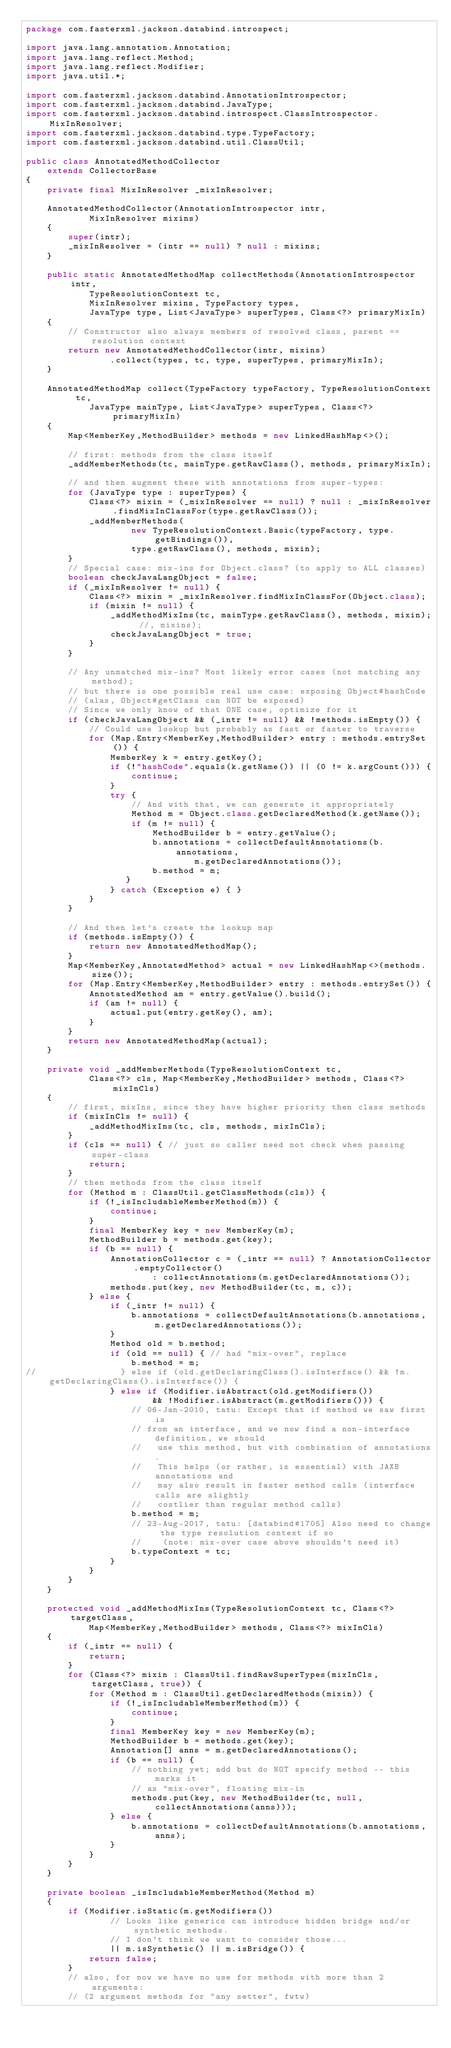<code> <loc_0><loc_0><loc_500><loc_500><_Java_>package com.fasterxml.jackson.databind.introspect;

import java.lang.annotation.Annotation;
import java.lang.reflect.Method;
import java.lang.reflect.Modifier;
import java.util.*;

import com.fasterxml.jackson.databind.AnnotationIntrospector;
import com.fasterxml.jackson.databind.JavaType;
import com.fasterxml.jackson.databind.introspect.ClassIntrospector.MixInResolver;
import com.fasterxml.jackson.databind.type.TypeFactory;
import com.fasterxml.jackson.databind.util.ClassUtil;

public class AnnotatedMethodCollector
    extends CollectorBase
{
    private final MixInResolver _mixInResolver;

    AnnotatedMethodCollector(AnnotationIntrospector intr,
            MixInResolver mixins)
    {
        super(intr);
        _mixInResolver = (intr == null) ? null : mixins;
    }

    public static AnnotatedMethodMap collectMethods(AnnotationIntrospector intr,
            TypeResolutionContext tc,
            MixInResolver mixins, TypeFactory types,
            JavaType type, List<JavaType> superTypes, Class<?> primaryMixIn)
    {
        // Constructor also always members of resolved class, parent == resolution context
        return new AnnotatedMethodCollector(intr, mixins)
                .collect(types, tc, type, superTypes, primaryMixIn);
    }

    AnnotatedMethodMap collect(TypeFactory typeFactory, TypeResolutionContext tc,
            JavaType mainType, List<JavaType> superTypes, Class<?> primaryMixIn)
    {
        Map<MemberKey,MethodBuilder> methods = new LinkedHashMap<>();
        
        // first: methods from the class itself
        _addMemberMethods(tc, mainType.getRawClass(), methods, primaryMixIn);

        // and then augment these with annotations from super-types:
        for (JavaType type : superTypes) {
            Class<?> mixin = (_mixInResolver == null) ? null : _mixInResolver.findMixInClassFor(type.getRawClass());
            _addMemberMethods(
                    new TypeResolutionContext.Basic(typeFactory, type.getBindings()),
                    type.getRawClass(), methods, mixin);
        }
        // Special case: mix-ins for Object.class? (to apply to ALL classes)
        boolean checkJavaLangObject = false;
        if (_mixInResolver != null) {
            Class<?> mixin = _mixInResolver.findMixInClassFor(Object.class);
            if (mixin != null) {
                _addMethodMixIns(tc, mainType.getRawClass(), methods, mixin); //, mixins);
                checkJavaLangObject = true;
            }
        }

        // Any unmatched mix-ins? Most likely error cases (not matching any method);
        // but there is one possible real use case: exposing Object#hashCode
        // (alas, Object#getClass can NOT be exposed)
        // Since we only know of that ONE case, optimize for it
        if (checkJavaLangObject && (_intr != null) && !methods.isEmpty()) {
            // Could use lookup but probably as fast or faster to traverse
            for (Map.Entry<MemberKey,MethodBuilder> entry : methods.entrySet()) {
                MemberKey k = entry.getKey();
                if (!"hashCode".equals(k.getName()) || (0 != k.argCount())) {
                    continue;
                }
                try {
                    // And with that, we can generate it appropriately
                    Method m = Object.class.getDeclaredMethod(k.getName());
                    if (m != null) {
                        MethodBuilder b = entry.getValue();
                        b.annotations = collectDefaultAnnotations(b.annotations,
                                m.getDeclaredAnnotations());
                        b.method = m;
                   }
                } catch (Exception e) { }
            }
        }

        // And then let's create the lookup map
        if (methods.isEmpty()) {
            return new AnnotatedMethodMap();
        }
        Map<MemberKey,AnnotatedMethod> actual = new LinkedHashMap<>(methods.size());
        for (Map.Entry<MemberKey,MethodBuilder> entry : methods.entrySet()) {
            AnnotatedMethod am = entry.getValue().build();
            if (am != null) {
                actual.put(entry.getKey(), am);
            }
        }
        return new AnnotatedMethodMap(actual);
    }

    private void _addMemberMethods(TypeResolutionContext tc,
            Class<?> cls, Map<MemberKey,MethodBuilder> methods, Class<?> mixInCls)
    {
        // first, mixIns, since they have higher priority then class methods
        if (mixInCls != null) {
            _addMethodMixIns(tc, cls, methods, mixInCls);
        }
        if (cls == null) { // just so caller need not check when passing super-class
            return;
        }
        // then methods from the class itself
        for (Method m : ClassUtil.getClassMethods(cls)) {
            if (!_isIncludableMemberMethod(m)) {
                continue;
            }
            final MemberKey key = new MemberKey(m);
            MethodBuilder b = methods.get(key);
            if (b == null) {
                AnnotationCollector c = (_intr == null) ? AnnotationCollector.emptyCollector()
                        : collectAnnotations(m.getDeclaredAnnotations());
                methods.put(key, new MethodBuilder(tc, m, c));
            } else {
                if (_intr != null) {
                    b.annotations = collectDefaultAnnotations(b.annotations, m.getDeclaredAnnotations());
                }
                Method old = b.method;
                if (old == null) { // had "mix-over", replace
                    b.method = m;
//                } else if (old.getDeclaringClass().isInterface() && !m.getDeclaringClass().isInterface()) {
                } else if (Modifier.isAbstract(old.getModifiers())
                        && !Modifier.isAbstract(m.getModifiers())) {
                    // 06-Jan-2010, tatu: Except that if method we saw first is
                    // from an interface, and we now find a non-interface definition, we should
                    //   use this method, but with combination of annotations.
                    //   This helps (or rather, is essential) with JAXB annotations and
                    //   may also result in faster method calls (interface calls are slightly
                    //   costlier than regular method calls)
                    b.method = m;
                    // 23-Aug-2017, tatu: [databind#1705] Also need to change the type resolution context if so
                    //    (note: mix-over case above shouldn't need it)
                    b.typeContext = tc;
                }
            }
        }
    }

    protected void _addMethodMixIns(TypeResolutionContext tc, Class<?> targetClass,
            Map<MemberKey,MethodBuilder> methods, Class<?> mixInCls)
    {
        if (_intr == null) {
            return;
        }
        for (Class<?> mixin : ClassUtil.findRawSuperTypes(mixInCls, targetClass, true)) {
            for (Method m : ClassUtil.getDeclaredMethods(mixin)) {
                if (!_isIncludableMemberMethod(m)) {
                    continue;
                }
                final MemberKey key = new MemberKey(m);
                MethodBuilder b = methods.get(key);
                Annotation[] anns = m.getDeclaredAnnotations();
                if (b == null) {
                    // nothing yet; add but do NOT specify method -- this marks it
                    // as "mix-over", floating mix-in
                    methods.put(key, new MethodBuilder(tc, null, collectAnnotations(anns)));
                } else {
                    b.annotations = collectDefaultAnnotations(b.annotations, anns);
                }
            }
        }
    }

    private boolean _isIncludableMemberMethod(Method m)
    {
        if (Modifier.isStatic(m.getModifiers())
                // Looks like generics can introduce hidden bridge and/or synthetic methods.
                // I don't think we want to consider those...
                || m.isSynthetic() || m.isBridge()) {
            return false;
        }
        // also, for now we have no use for methods with more than 2 arguments:
        // (2 argument methods for "any setter", fwtw)</code> 